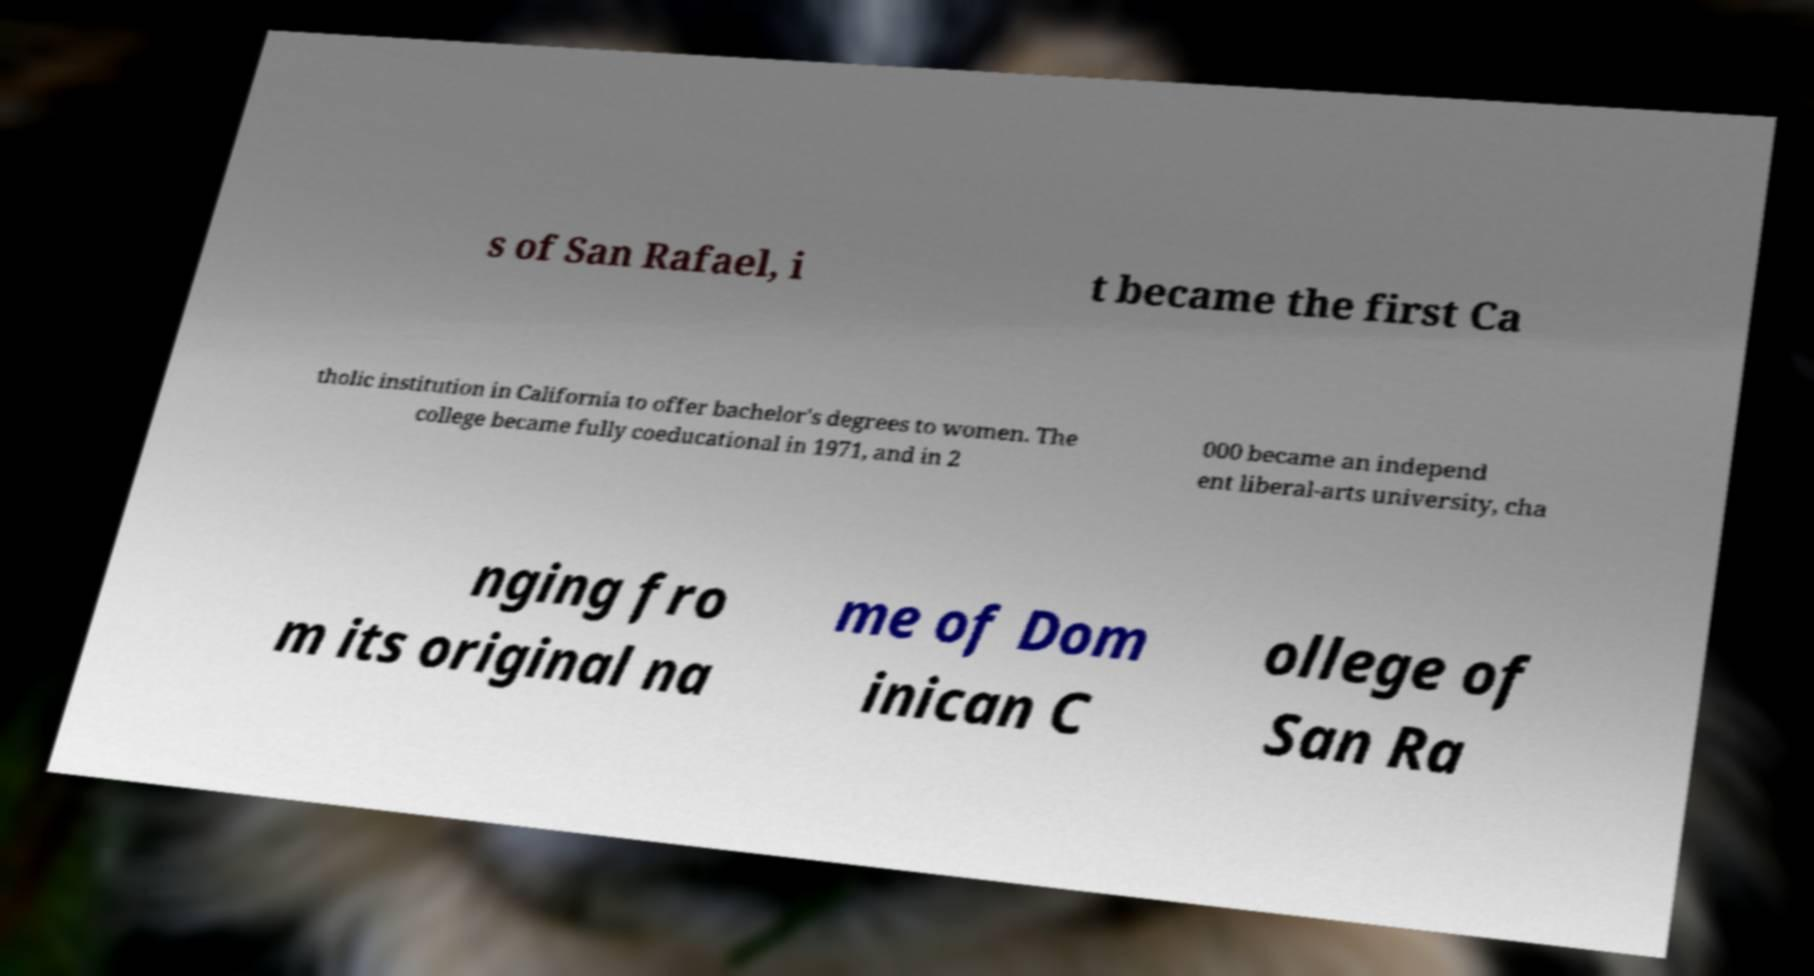For documentation purposes, I need the text within this image transcribed. Could you provide that? s of San Rafael, i t became the first Ca tholic institution in California to offer bachelor's degrees to women. The college became fully coeducational in 1971, and in 2 000 became an independ ent liberal-arts university, cha nging fro m its original na me of Dom inican C ollege of San Ra 